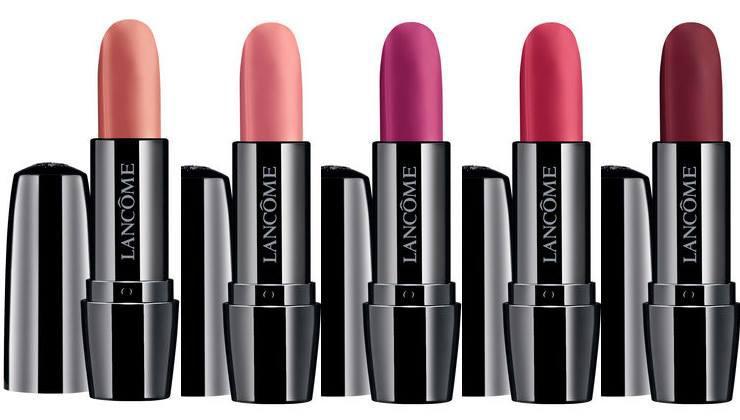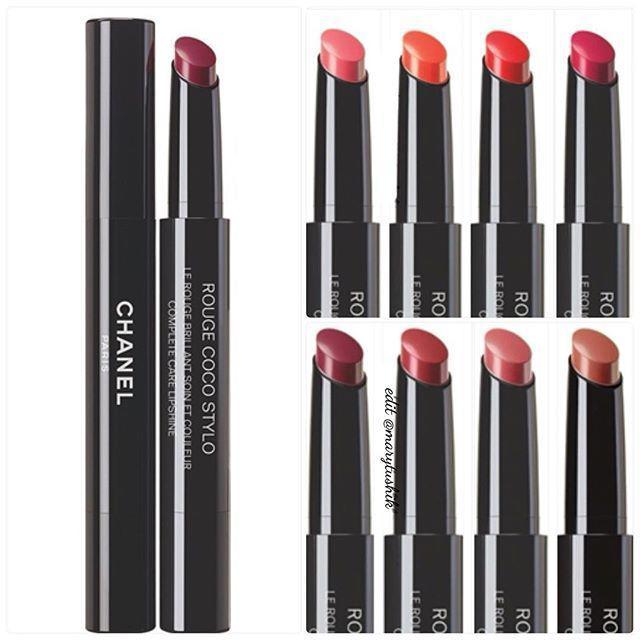The first image is the image on the left, the second image is the image on the right. Given the left and right images, does the statement "Only one lipstick cap is shown right next to a lipstick." hold true? Answer yes or no. No. The first image is the image on the left, the second image is the image on the right. Analyze the images presented: Is the assertion "An image with three lip cosmetics includes at least one product shaped like a crayon." valid? Answer yes or no. No. 